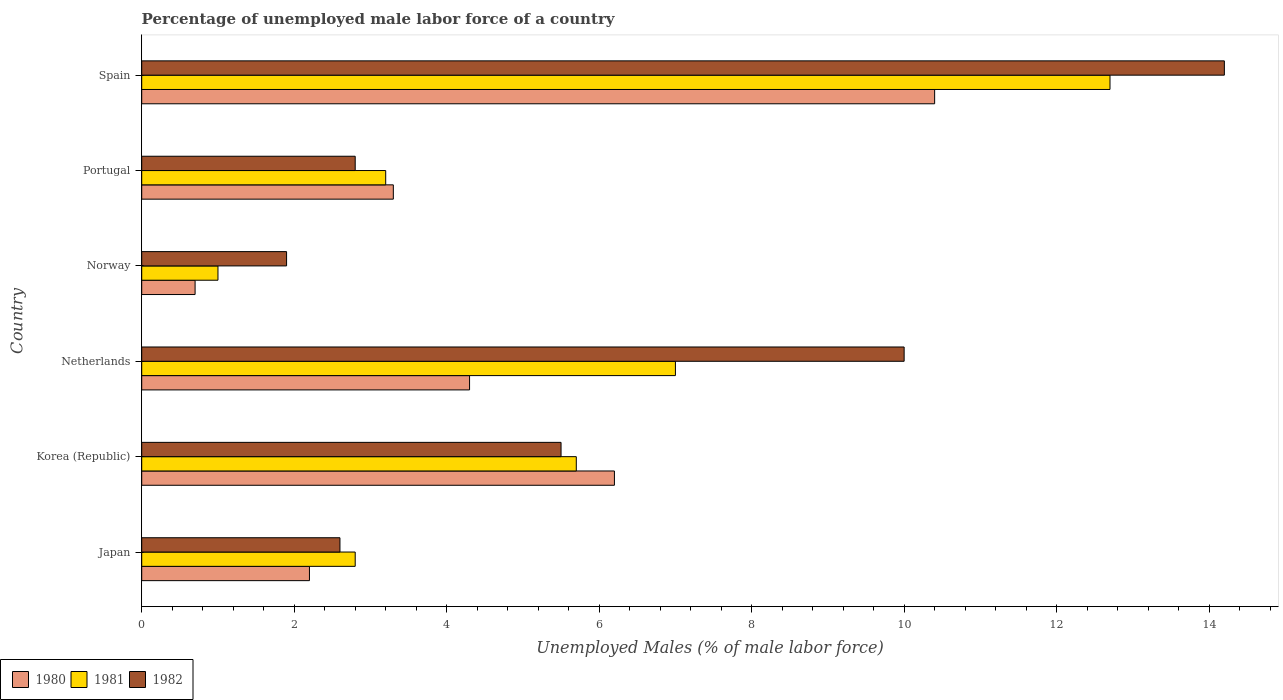How many different coloured bars are there?
Provide a short and direct response. 3. How many groups of bars are there?
Offer a terse response. 6. Are the number of bars on each tick of the Y-axis equal?
Make the answer very short. Yes. What is the label of the 3rd group of bars from the top?
Your response must be concise. Norway. In how many cases, is the number of bars for a given country not equal to the number of legend labels?
Make the answer very short. 0. What is the percentage of unemployed male labor force in 1982 in Japan?
Keep it short and to the point. 2.6. Across all countries, what is the maximum percentage of unemployed male labor force in 1981?
Your answer should be very brief. 12.7. Across all countries, what is the minimum percentage of unemployed male labor force in 1982?
Keep it short and to the point. 1.9. In which country was the percentage of unemployed male labor force in 1981 maximum?
Offer a terse response. Spain. In which country was the percentage of unemployed male labor force in 1980 minimum?
Provide a succinct answer. Norway. What is the total percentage of unemployed male labor force in 1980 in the graph?
Offer a terse response. 27.1. What is the difference between the percentage of unemployed male labor force in 1982 in Korea (Republic) and that in Spain?
Your answer should be very brief. -8.7. What is the difference between the percentage of unemployed male labor force in 1982 in Netherlands and the percentage of unemployed male labor force in 1980 in Norway?
Provide a short and direct response. 9.3. What is the average percentage of unemployed male labor force in 1982 per country?
Offer a very short reply. 6.17. What is the difference between the percentage of unemployed male labor force in 1982 and percentage of unemployed male labor force in 1980 in Korea (Republic)?
Provide a succinct answer. -0.7. In how many countries, is the percentage of unemployed male labor force in 1981 greater than 5.6 %?
Provide a succinct answer. 3. What is the ratio of the percentage of unemployed male labor force in 1982 in Korea (Republic) to that in Portugal?
Your answer should be very brief. 1.96. Is the percentage of unemployed male labor force in 1980 in Japan less than that in Norway?
Keep it short and to the point. No. What is the difference between the highest and the second highest percentage of unemployed male labor force in 1980?
Ensure brevity in your answer.  4.2. What is the difference between the highest and the lowest percentage of unemployed male labor force in 1981?
Offer a terse response. 11.7. In how many countries, is the percentage of unemployed male labor force in 1982 greater than the average percentage of unemployed male labor force in 1982 taken over all countries?
Your answer should be compact. 2. Are all the bars in the graph horizontal?
Give a very brief answer. Yes. How many countries are there in the graph?
Provide a succinct answer. 6. What is the difference between two consecutive major ticks on the X-axis?
Your response must be concise. 2. Does the graph contain any zero values?
Your answer should be very brief. No. Where does the legend appear in the graph?
Offer a very short reply. Bottom left. How are the legend labels stacked?
Provide a short and direct response. Horizontal. What is the title of the graph?
Offer a terse response. Percentage of unemployed male labor force of a country. Does "2012" appear as one of the legend labels in the graph?
Your answer should be very brief. No. What is the label or title of the X-axis?
Your response must be concise. Unemployed Males (% of male labor force). What is the label or title of the Y-axis?
Offer a terse response. Country. What is the Unemployed Males (% of male labor force) in 1980 in Japan?
Provide a short and direct response. 2.2. What is the Unemployed Males (% of male labor force) of 1981 in Japan?
Your response must be concise. 2.8. What is the Unemployed Males (% of male labor force) in 1982 in Japan?
Keep it short and to the point. 2.6. What is the Unemployed Males (% of male labor force) in 1980 in Korea (Republic)?
Your answer should be compact. 6.2. What is the Unemployed Males (% of male labor force) in 1981 in Korea (Republic)?
Your answer should be very brief. 5.7. What is the Unemployed Males (% of male labor force) of 1980 in Netherlands?
Offer a very short reply. 4.3. What is the Unemployed Males (% of male labor force) in 1981 in Netherlands?
Your response must be concise. 7. What is the Unemployed Males (% of male labor force) of 1982 in Netherlands?
Provide a succinct answer. 10. What is the Unemployed Males (% of male labor force) of 1980 in Norway?
Ensure brevity in your answer.  0.7. What is the Unemployed Males (% of male labor force) of 1982 in Norway?
Offer a terse response. 1.9. What is the Unemployed Males (% of male labor force) of 1980 in Portugal?
Make the answer very short. 3.3. What is the Unemployed Males (% of male labor force) in 1981 in Portugal?
Your answer should be compact. 3.2. What is the Unemployed Males (% of male labor force) in 1982 in Portugal?
Keep it short and to the point. 2.8. What is the Unemployed Males (% of male labor force) of 1980 in Spain?
Provide a short and direct response. 10.4. What is the Unemployed Males (% of male labor force) in 1981 in Spain?
Provide a short and direct response. 12.7. What is the Unemployed Males (% of male labor force) of 1982 in Spain?
Provide a short and direct response. 14.2. Across all countries, what is the maximum Unemployed Males (% of male labor force) in 1980?
Give a very brief answer. 10.4. Across all countries, what is the maximum Unemployed Males (% of male labor force) of 1981?
Your answer should be compact. 12.7. Across all countries, what is the maximum Unemployed Males (% of male labor force) of 1982?
Provide a short and direct response. 14.2. Across all countries, what is the minimum Unemployed Males (% of male labor force) of 1980?
Provide a succinct answer. 0.7. Across all countries, what is the minimum Unemployed Males (% of male labor force) of 1981?
Your answer should be very brief. 1. Across all countries, what is the minimum Unemployed Males (% of male labor force) in 1982?
Provide a succinct answer. 1.9. What is the total Unemployed Males (% of male labor force) in 1980 in the graph?
Your answer should be very brief. 27.1. What is the total Unemployed Males (% of male labor force) of 1981 in the graph?
Your answer should be compact. 32.4. What is the difference between the Unemployed Males (% of male labor force) in 1980 in Japan and that in Korea (Republic)?
Keep it short and to the point. -4. What is the difference between the Unemployed Males (% of male labor force) in 1981 in Japan and that in Netherlands?
Your response must be concise. -4.2. What is the difference between the Unemployed Males (% of male labor force) in 1982 in Japan and that in Netherlands?
Ensure brevity in your answer.  -7.4. What is the difference between the Unemployed Males (% of male labor force) of 1980 in Japan and that in Portugal?
Offer a terse response. -1.1. What is the difference between the Unemployed Males (% of male labor force) in 1982 in Japan and that in Spain?
Your response must be concise. -11.6. What is the difference between the Unemployed Males (% of male labor force) in 1982 in Korea (Republic) and that in Netherlands?
Offer a very short reply. -4.5. What is the difference between the Unemployed Males (% of male labor force) in 1980 in Korea (Republic) and that in Norway?
Keep it short and to the point. 5.5. What is the difference between the Unemployed Males (% of male labor force) of 1981 in Korea (Republic) and that in Norway?
Offer a very short reply. 4.7. What is the difference between the Unemployed Males (% of male labor force) in 1982 in Korea (Republic) and that in Norway?
Offer a very short reply. 3.6. What is the difference between the Unemployed Males (% of male labor force) in 1980 in Korea (Republic) and that in Portugal?
Offer a very short reply. 2.9. What is the difference between the Unemployed Males (% of male labor force) in 1981 in Korea (Republic) and that in Portugal?
Offer a terse response. 2.5. What is the difference between the Unemployed Males (% of male labor force) in 1982 in Korea (Republic) and that in Portugal?
Offer a very short reply. 2.7. What is the difference between the Unemployed Males (% of male labor force) in 1980 in Korea (Republic) and that in Spain?
Make the answer very short. -4.2. What is the difference between the Unemployed Males (% of male labor force) of 1981 in Netherlands and that in Norway?
Your response must be concise. 6. What is the difference between the Unemployed Males (% of male labor force) in 1980 in Netherlands and that in Portugal?
Offer a terse response. 1. What is the difference between the Unemployed Males (% of male labor force) of 1981 in Norway and that in Spain?
Provide a succinct answer. -11.7. What is the difference between the Unemployed Males (% of male labor force) of 1982 in Norway and that in Spain?
Your response must be concise. -12.3. What is the difference between the Unemployed Males (% of male labor force) in 1980 in Portugal and that in Spain?
Provide a succinct answer. -7.1. What is the difference between the Unemployed Males (% of male labor force) in 1980 in Japan and the Unemployed Males (% of male labor force) in 1981 in Korea (Republic)?
Keep it short and to the point. -3.5. What is the difference between the Unemployed Males (% of male labor force) of 1981 in Japan and the Unemployed Males (% of male labor force) of 1982 in Korea (Republic)?
Offer a terse response. -2.7. What is the difference between the Unemployed Males (% of male labor force) in 1980 in Japan and the Unemployed Males (% of male labor force) in 1982 in Netherlands?
Ensure brevity in your answer.  -7.8. What is the difference between the Unemployed Males (% of male labor force) in 1980 in Japan and the Unemployed Males (% of male labor force) in 1981 in Spain?
Offer a terse response. -10.5. What is the difference between the Unemployed Males (% of male labor force) in 1981 in Korea (Republic) and the Unemployed Males (% of male labor force) in 1982 in Netherlands?
Your answer should be compact. -4.3. What is the difference between the Unemployed Males (% of male labor force) of 1980 in Korea (Republic) and the Unemployed Males (% of male labor force) of 1982 in Norway?
Your response must be concise. 4.3. What is the difference between the Unemployed Males (% of male labor force) of 1980 in Korea (Republic) and the Unemployed Males (% of male labor force) of 1981 in Portugal?
Your answer should be compact. 3. What is the difference between the Unemployed Males (% of male labor force) in 1980 in Korea (Republic) and the Unemployed Males (% of male labor force) in 1981 in Spain?
Provide a succinct answer. -6.5. What is the difference between the Unemployed Males (% of male labor force) in 1980 in Netherlands and the Unemployed Males (% of male labor force) in 1981 in Norway?
Ensure brevity in your answer.  3.3. What is the difference between the Unemployed Males (% of male labor force) of 1980 in Netherlands and the Unemployed Males (% of male labor force) of 1981 in Portugal?
Offer a very short reply. 1.1. What is the difference between the Unemployed Males (% of male labor force) in 1980 in Netherlands and the Unemployed Males (% of male labor force) in 1981 in Spain?
Offer a terse response. -8.4. What is the difference between the Unemployed Males (% of male labor force) of 1980 in Norway and the Unemployed Males (% of male labor force) of 1981 in Portugal?
Your answer should be compact. -2.5. What is the difference between the Unemployed Males (% of male labor force) of 1980 in Norway and the Unemployed Males (% of male labor force) of 1982 in Portugal?
Your answer should be very brief. -2.1. What is the difference between the Unemployed Males (% of male labor force) of 1981 in Norway and the Unemployed Males (% of male labor force) of 1982 in Spain?
Make the answer very short. -13.2. What is the difference between the Unemployed Males (% of male labor force) in 1980 in Portugal and the Unemployed Males (% of male labor force) in 1981 in Spain?
Ensure brevity in your answer.  -9.4. What is the average Unemployed Males (% of male labor force) in 1980 per country?
Provide a succinct answer. 4.52. What is the average Unemployed Males (% of male labor force) in 1982 per country?
Provide a short and direct response. 6.17. What is the difference between the Unemployed Males (% of male labor force) of 1980 and Unemployed Males (% of male labor force) of 1981 in Korea (Republic)?
Offer a very short reply. 0.5. What is the difference between the Unemployed Males (% of male labor force) of 1981 and Unemployed Males (% of male labor force) of 1982 in Korea (Republic)?
Offer a terse response. 0.2. What is the difference between the Unemployed Males (% of male labor force) of 1980 and Unemployed Males (% of male labor force) of 1981 in Netherlands?
Give a very brief answer. -2.7. What is the difference between the Unemployed Males (% of male labor force) of 1980 and Unemployed Males (% of male labor force) of 1982 in Netherlands?
Keep it short and to the point. -5.7. What is the difference between the Unemployed Males (% of male labor force) in 1981 and Unemployed Males (% of male labor force) in 1982 in Netherlands?
Your answer should be very brief. -3. What is the difference between the Unemployed Males (% of male labor force) of 1980 and Unemployed Males (% of male labor force) of 1982 in Norway?
Offer a very short reply. -1.2. What is the difference between the Unemployed Males (% of male labor force) of 1980 and Unemployed Males (% of male labor force) of 1981 in Portugal?
Make the answer very short. 0.1. What is the difference between the Unemployed Males (% of male labor force) in 1980 and Unemployed Males (% of male labor force) in 1982 in Portugal?
Offer a terse response. 0.5. What is the difference between the Unemployed Males (% of male labor force) in 1981 and Unemployed Males (% of male labor force) in 1982 in Portugal?
Offer a terse response. 0.4. What is the difference between the Unemployed Males (% of male labor force) of 1980 and Unemployed Males (% of male labor force) of 1981 in Spain?
Provide a succinct answer. -2.3. What is the ratio of the Unemployed Males (% of male labor force) of 1980 in Japan to that in Korea (Republic)?
Keep it short and to the point. 0.35. What is the ratio of the Unemployed Males (% of male labor force) of 1981 in Japan to that in Korea (Republic)?
Ensure brevity in your answer.  0.49. What is the ratio of the Unemployed Males (% of male labor force) of 1982 in Japan to that in Korea (Republic)?
Offer a very short reply. 0.47. What is the ratio of the Unemployed Males (% of male labor force) of 1980 in Japan to that in Netherlands?
Your response must be concise. 0.51. What is the ratio of the Unemployed Males (% of male labor force) in 1981 in Japan to that in Netherlands?
Provide a short and direct response. 0.4. What is the ratio of the Unemployed Males (% of male labor force) of 1982 in Japan to that in Netherlands?
Your answer should be very brief. 0.26. What is the ratio of the Unemployed Males (% of male labor force) of 1980 in Japan to that in Norway?
Provide a short and direct response. 3.14. What is the ratio of the Unemployed Males (% of male labor force) in 1981 in Japan to that in Norway?
Provide a short and direct response. 2.8. What is the ratio of the Unemployed Males (% of male labor force) in 1982 in Japan to that in Norway?
Your answer should be very brief. 1.37. What is the ratio of the Unemployed Males (% of male labor force) of 1982 in Japan to that in Portugal?
Ensure brevity in your answer.  0.93. What is the ratio of the Unemployed Males (% of male labor force) of 1980 in Japan to that in Spain?
Provide a short and direct response. 0.21. What is the ratio of the Unemployed Males (% of male labor force) of 1981 in Japan to that in Spain?
Your answer should be very brief. 0.22. What is the ratio of the Unemployed Males (% of male labor force) in 1982 in Japan to that in Spain?
Offer a terse response. 0.18. What is the ratio of the Unemployed Males (% of male labor force) of 1980 in Korea (Republic) to that in Netherlands?
Make the answer very short. 1.44. What is the ratio of the Unemployed Males (% of male labor force) in 1981 in Korea (Republic) to that in Netherlands?
Ensure brevity in your answer.  0.81. What is the ratio of the Unemployed Males (% of male labor force) of 1982 in Korea (Republic) to that in Netherlands?
Offer a very short reply. 0.55. What is the ratio of the Unemployed Males (% of male labor force) in 1980 in Korea (Republic) to that in Norway?
Keep it short and to the point. 8.86. What is the ratio of the Unemployed Males (% of male labor force) of 1981 in Korea (Republic) to that in Norway?
Provide a succinct answer. 5.7. What is the ratio of the Unemployed Males (% of male labor force) in 1982 in Korea (Republic) to that in Norway?
Make the answer very short. 2.89. What is the ratio of the Unemployed Males (% of male labor force) in 1980 in Korea (Republic) to that in Portugal?
Your answer should be very brief. 1.88. What is the ratio of the Unemployed Males (% of male labor force) in 1981 in Korea (Republic) to that in Portugal?
Provide a succinct answer. 1.78. What is the ratio of the Unemployed Males (% of male labor force) in 1982 in Korea (Republic) to that in Portugal?
Your answer should be very brief. 1.96. What is the ratio of the Unemployed Males (% of male labor force) of 1980 in Korea (Republic) to that in Spain?
Offer a very short reply. 0.6. What is the ratio of the Unemployed Males (% of male labor force) in 1981 in Korea (Republic) to that in Spain?
Keep it short and to the point. 0.45. What is the ratio of the Unemployed Males (% of male labor force) in 1982 in Korea (Republic) to that in Spain?
Keep it short and to the point. 0.39. What is the ratio of the Unemployed Males (% of male labor force) of 1980 in Netherlands to that in Norway?
Your answer should be very brief. 6.14. What is the ratio of the Unemployed Males (% of male labor force) of 1982 in Netherlands to that in Norway?
Keep it short and to the point. 5.26. What is the ratio of the Unemployed Males (% of male labor force) of 1980 in Netherlands to that in Portugal?
Provide a succinct answer. 1.3. What is the ratio of the Unemployed Males (% of male labor force) of 1981 in Netherlands to that in Portugal?
Ensure brevity in your answer.  2.19. What is the ratio of the Unemployed Males (% of male labor force) of 1982 in Netherlands to that in Portugal?
Your answer should be very brief. 3.57. What is the ratio of the Unemployed Males (% of male labor force) in 1980 in Netherlands to that in Spain?
Offer a terse response. 0.41. What is the ratio of the Unemployed Males (% of male labor force) of 1981 in Netherlands to that in Spain?
Offer a terse response. 0.55. What is the ratio of the Unemployed Males (% of male labor force) in 1982 in Netherlands to that in Spain?
Keep it short and to the point. 0.7. What is the ratio of the Unemployed Males (% of male labor force) of 1980 in Norway to that in Portugal?
Provide a succinct answer. 0.21. What is the ratio of the Unemployed Males (% of male labor force) of 1981 in Norway to that in Portugal?
Your response must be concise. 0.31. What is the ratio of the Unemployed Males (% of male labor force) of 1982 in Norway to that in Portugal?
Keep it short and to the point. 0.68. What is the ratio of the Unemployed Males (% of male labor force) of 1980 in Norway to that in Spain?
Keep it short and to the point. 0.07. What is the ratio of the Unemployed Males (% of male labor force) in 1981 in Norway to that in Spain?
Provide a succinct answer. 0.08. What is the ratio of the Unemployed Males (% of male labor force) of 1982 in Norway to that in Spain?
Provide a succinct answer. 0.13. What is the ratio of the Unemployed Males (% of male labor force) in 1980 in Portugal to that in Spain?
Give a very brief answer. 0.32. What is the ratio of the Unemployed Males (% of male labor force) of 1981 in Portugal to that in Spain?
Provide a short and direct response. 0.25. What is the ratio of the Unemployed Males (% of male labor force) in 1982 in Portugal to that in Spain?
Keep it short and to the point. 0.2. 